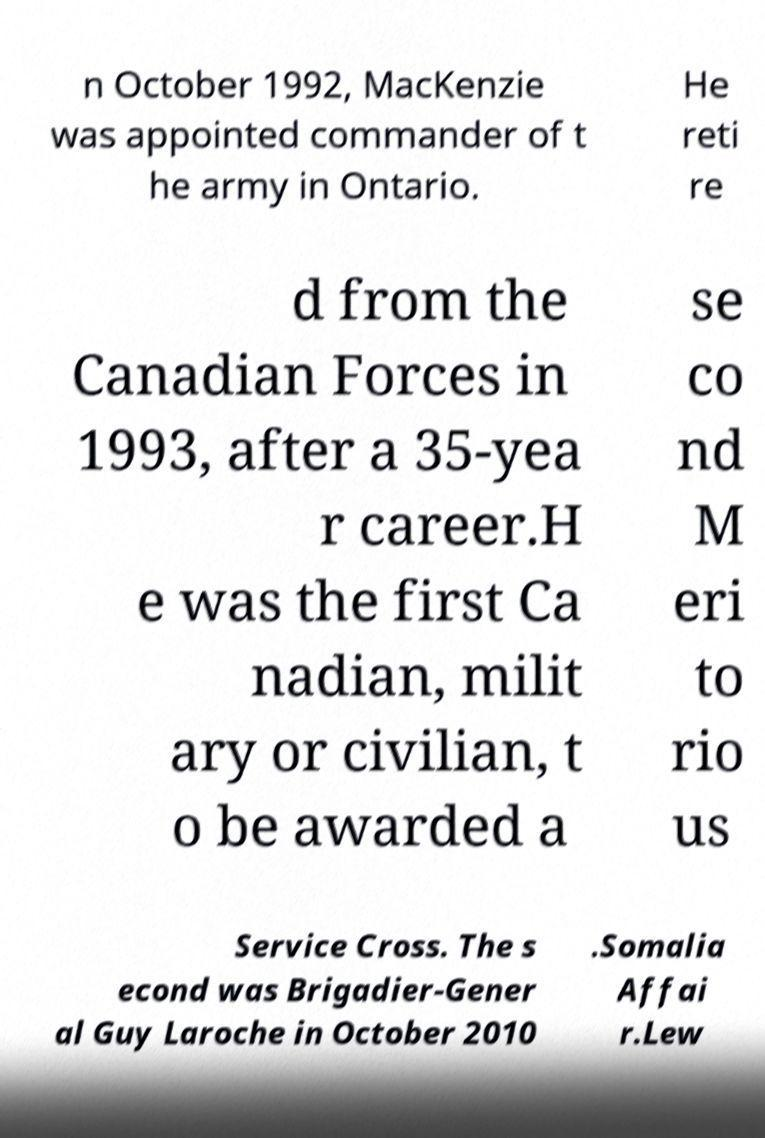Could you extract and type out the text from this image? n October 1992, MacKenzie was appointed commander of t he army in Ontario. He reti re d from the Canadian Forces in 1993, after a 35-yea r career.H e was the first Ca nadian, milit ary or civilian, t o be awarded a se co nd M eri to rio us Service Cross. The s econd was Brigadier-Gener al Guy Laroche in October 2010 .Somalia Affai r.Lew 